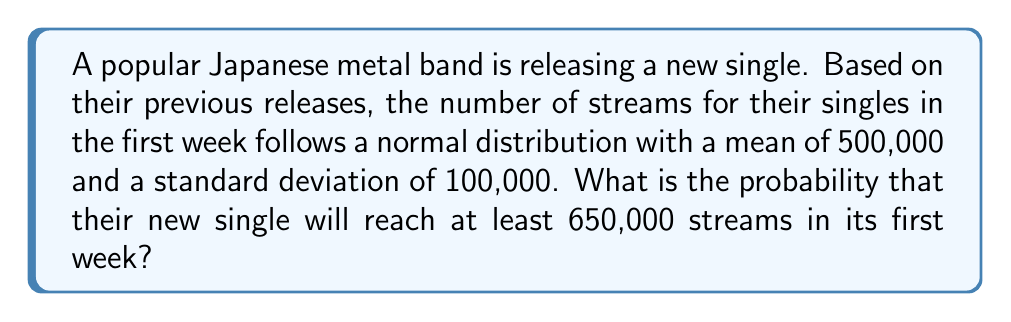Help me with this question. To solve this problem, we need to use the properties of the normal distribution and calculate a z-score.

Step 1: Identify the given information
- Mean (μ) = 500,000 streams
- Standard deviation (σ) = 100,000 streams
- Target value (x) = 650,000 streams

Step 2: Calculate the z-score
The z-score represents how many standard deviations the target value is from the mean.

$$ z = \frac{x - μ}{σ} = \frac{650,000 - 500,000}{100,000} = \frac{150,000}{100,000} = 1.5 $$

Step 3: Use the standard normal distribution table or calculator
We need to find P(X ≥ 650,000), which is equivalent to P(Z ≥ 1.5).

Using a standard normal distribution table or calculator, we find:
P(Z ≥ 1.5) ≈ 0.0668

Step 4: Interpret the result
The probability of the new single reaching at least 650,000 streams in its first week is approximately 0.0668 or 6.68%.
Answer: 0.0668 or 6.68% 